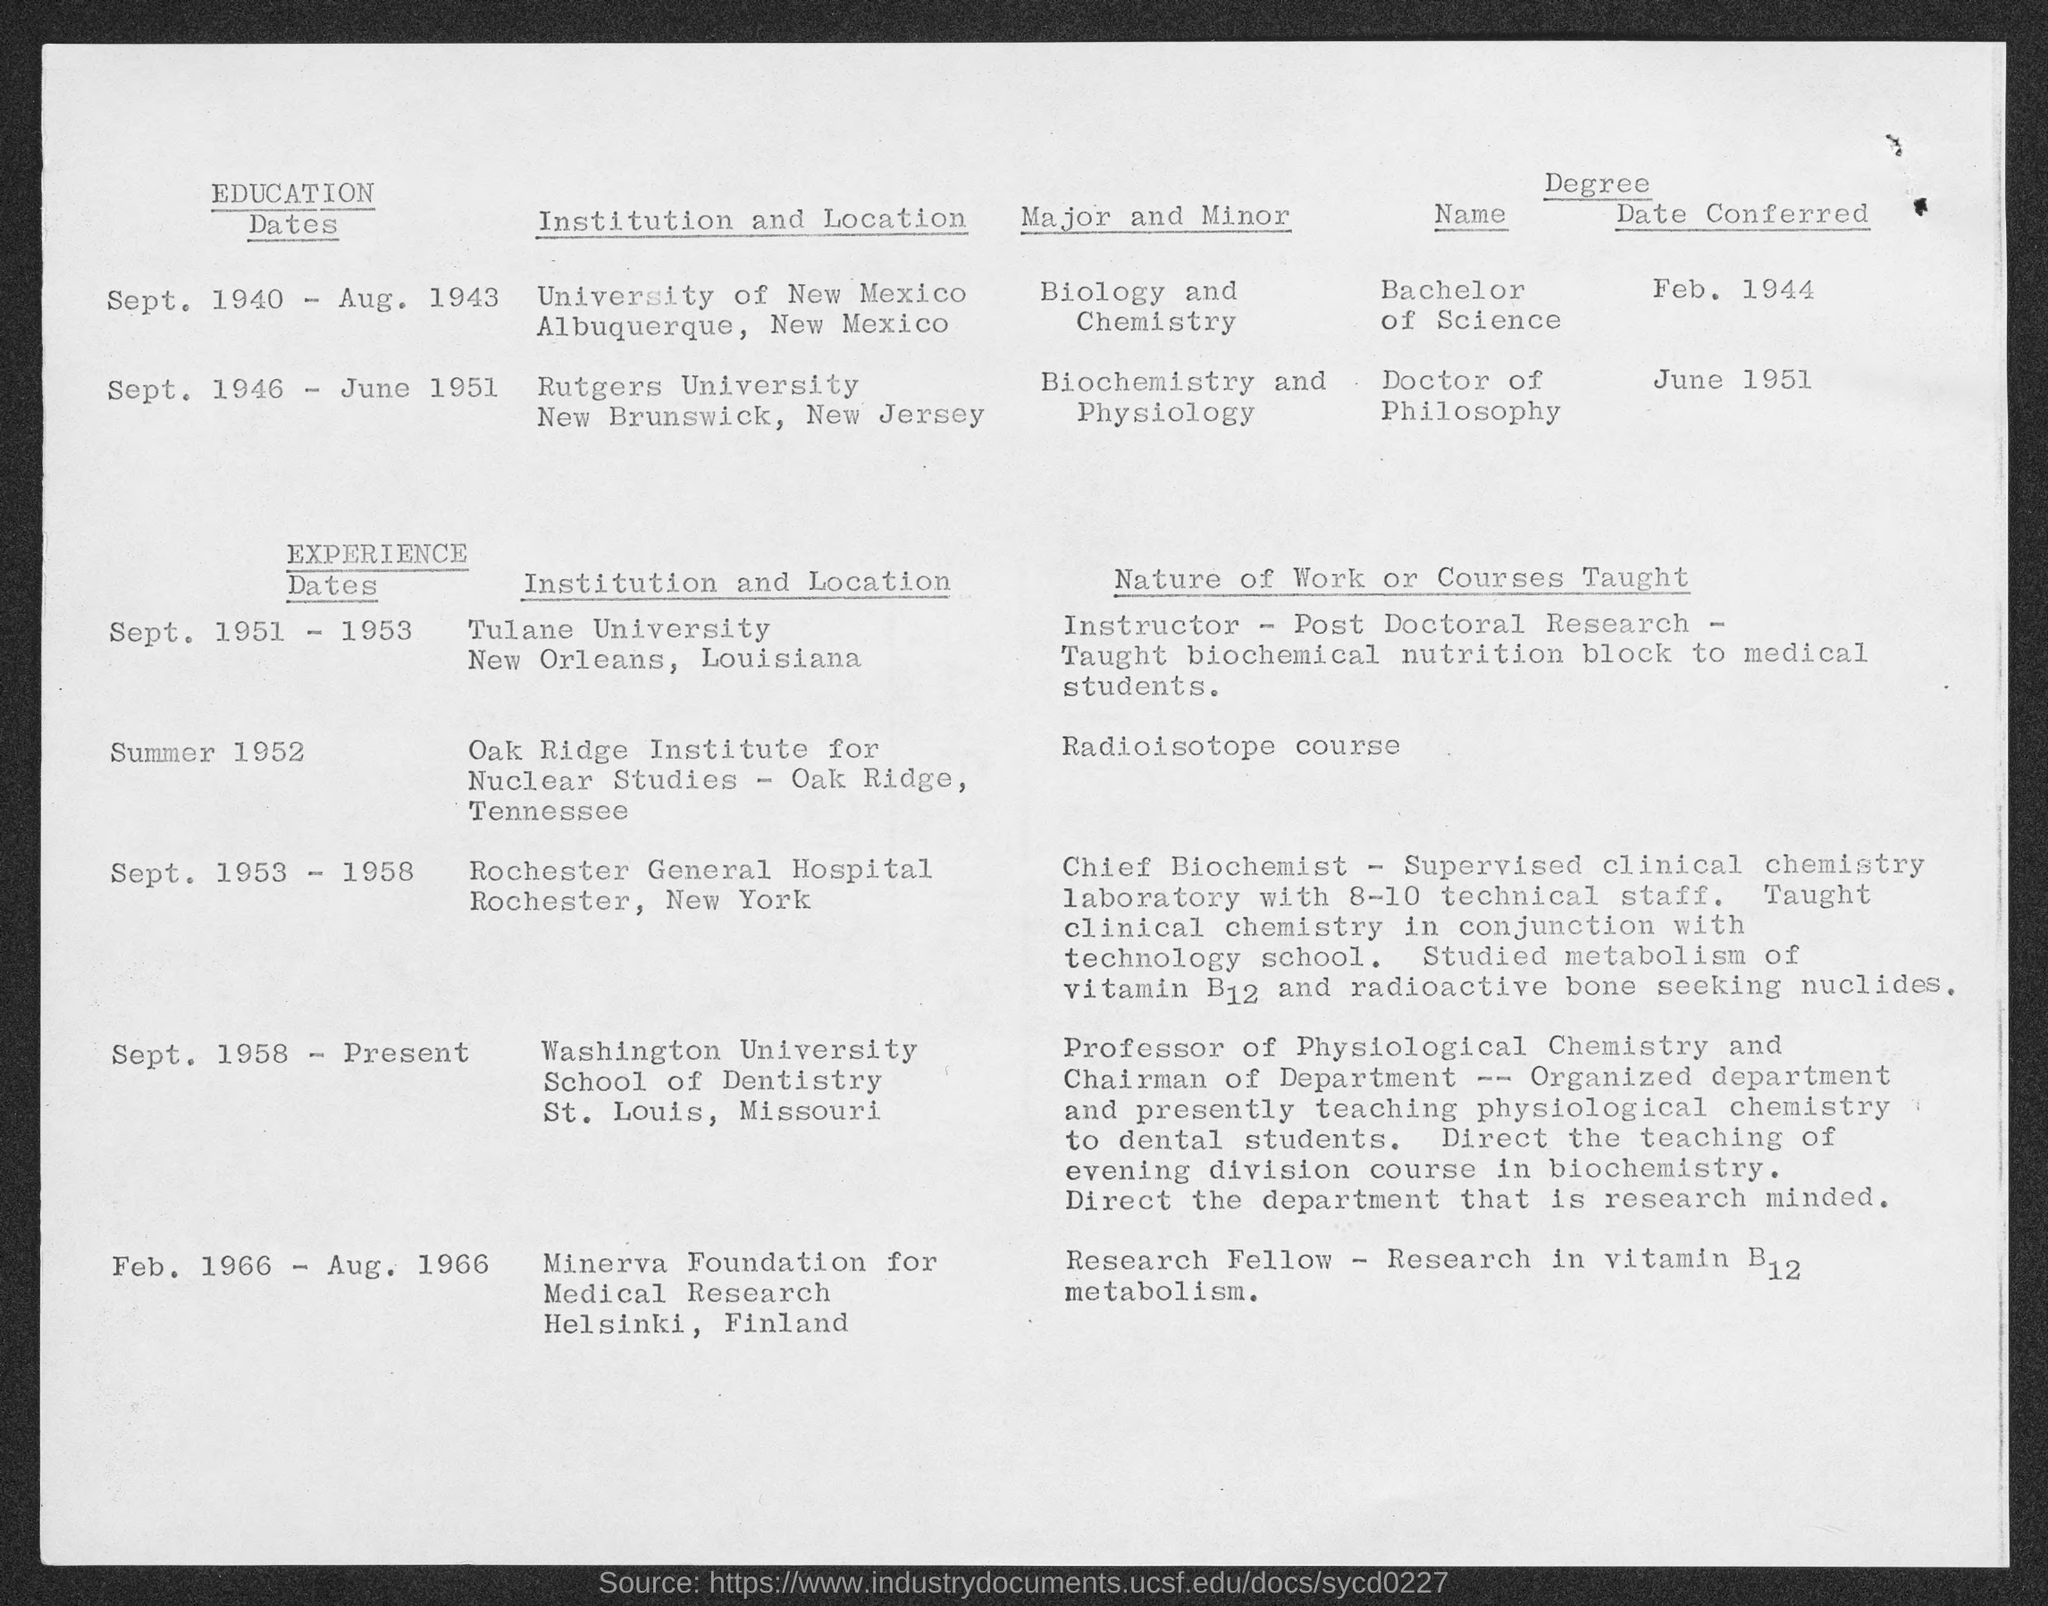Specify some key components in this picture. My major subjects at Rutgers University are Biochemistry and Physiology. 